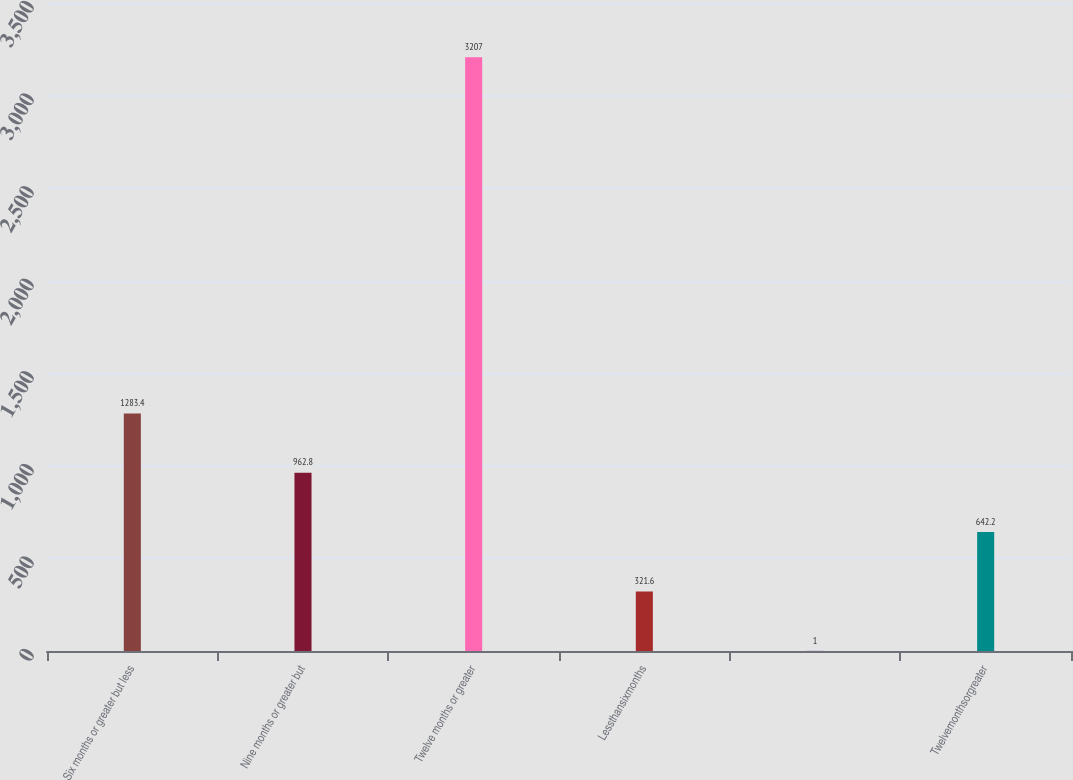<chart> <loc_0><loc_0><loc_500><loc_500><bar_chart><fcel>Six months or greater but less<fcel>Nine months or greater but<fcel>Twelve months or greater<fcel>Lessthansixmonths<fcel>Unnamed: 4<fcel>Twelvemonthsorgreater<nl><fcel>1283.4<fcel>962.8<fcel>3207<fcel>321.6<fcel>1<fcel>642.2<nl></chart> 